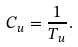Convert formula to latex. <formula><loc_0><loc_0><loc_500><loc_500>C _ { u } = \frac { 1 } { T _ { u } } .</formula> 